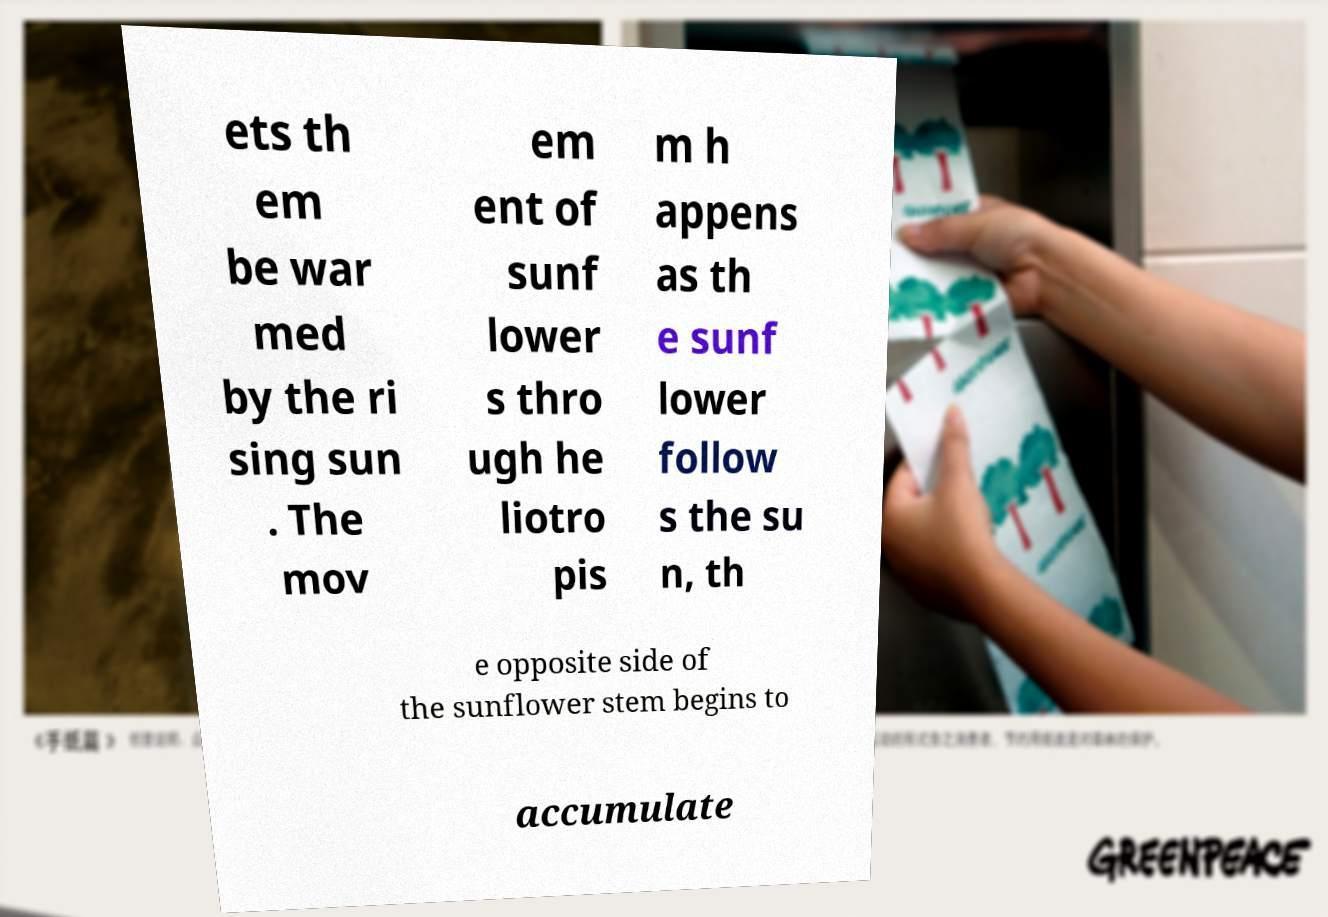What messages or text are displayed in this image? I need them in a readable, typed format. ets th em be war med by the ri sing sun . The mov em ent of sunf lower s thro ugh he liotro pis m h appens as th e sunf lower follow s the su n, th e opposite side of the sunflower stem begins to accumulate 